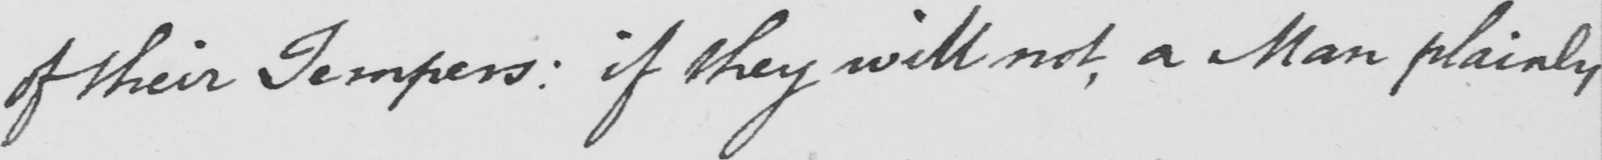Transcribe the text shown in this historical manuscript line. of their Tempers :  if they will not , a Man plainly 